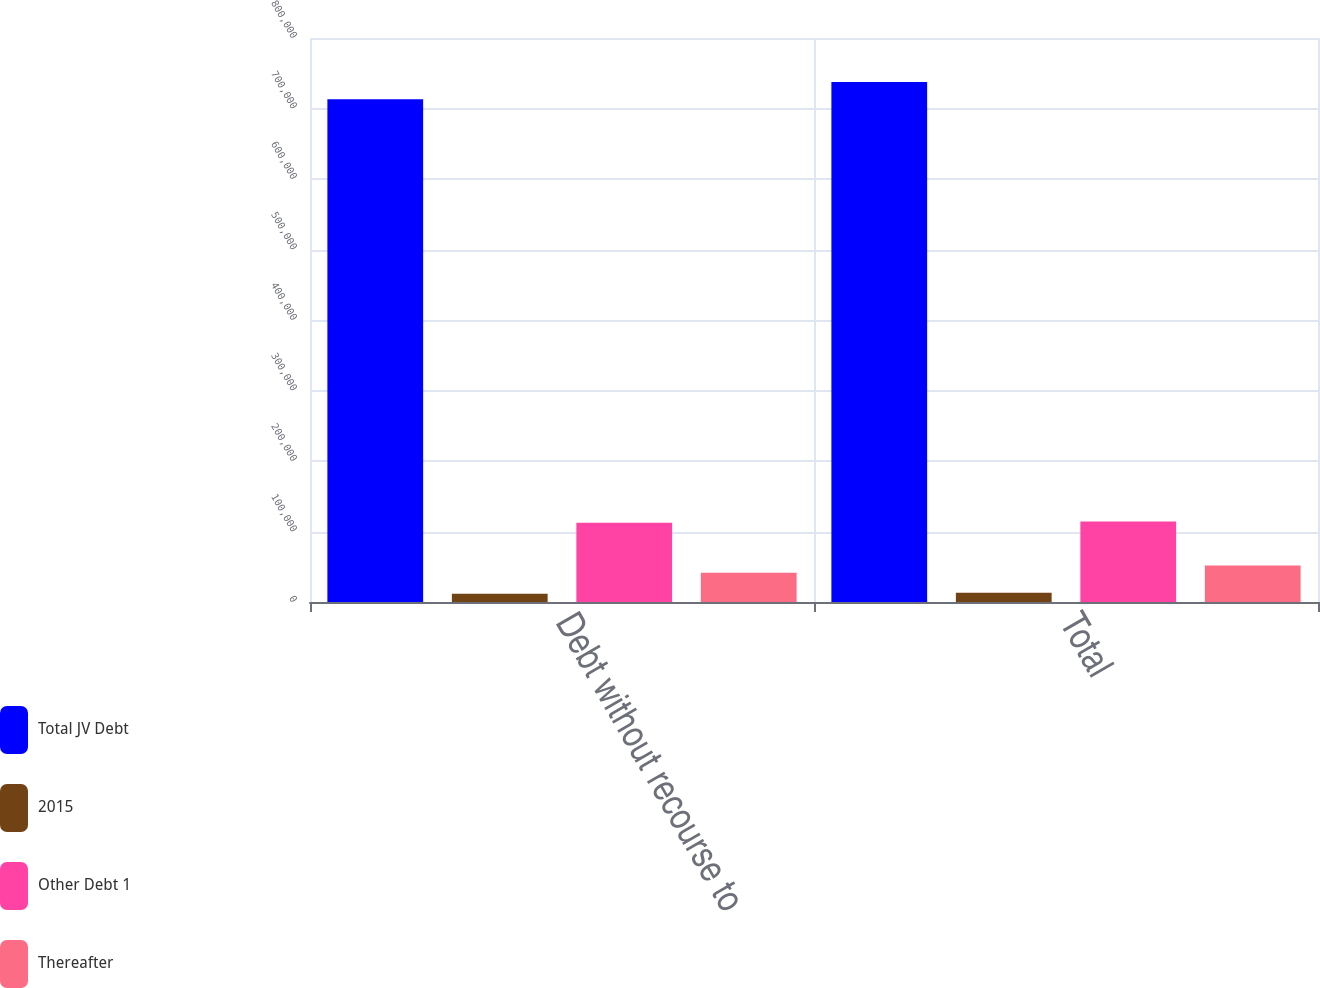<chart> <loc_0><loc_0><loc_500><loc_500><stacked_bar_chart><ecel><fcel>Debt without recourse to<fcel>Total<nl><fcel>Total JV Debt<fcel>713274<fcel>737755<nl><fcel>2015<fcel>11853<fcel>13173<nl><fcel>Other Debt 1<fcel>112585<fcel>114214<nl><fcel>Thereafter<fcel>41655<fcel>51931<nl></chart> 